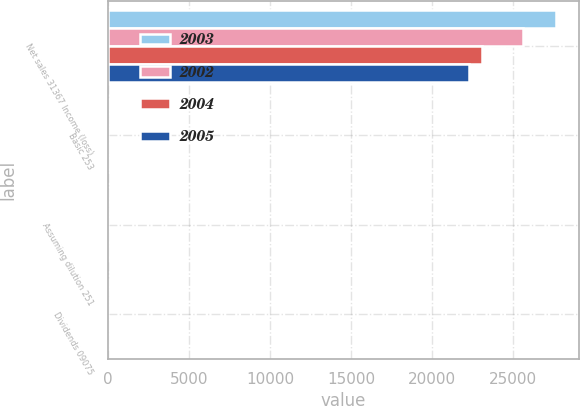<chart> <loc_0><loc_0><loc_500><loc_500><stacked_bar_chart><ecel><fcel>Net sales 31367 Income (loss)<fcel>Basic 253<fcel>Assuming dilution 251<fcel>Dividends 09075<nl><fcel>2003<fcel>27652<fcel>1.85<fcel>1.84<fcel>0.82<nl><fcel>2002<fcel>25593<fcel>1.45<fcel>1.45<fcel>0.75<nl><fcel>2004<fcel>23095<fcel>1.52<fcel>1.52<fcel>0.75<nl><fcel>2005<fcel>22261<fcel>0.31<fcel>0.31<fcel>0.75<nl></chart> 